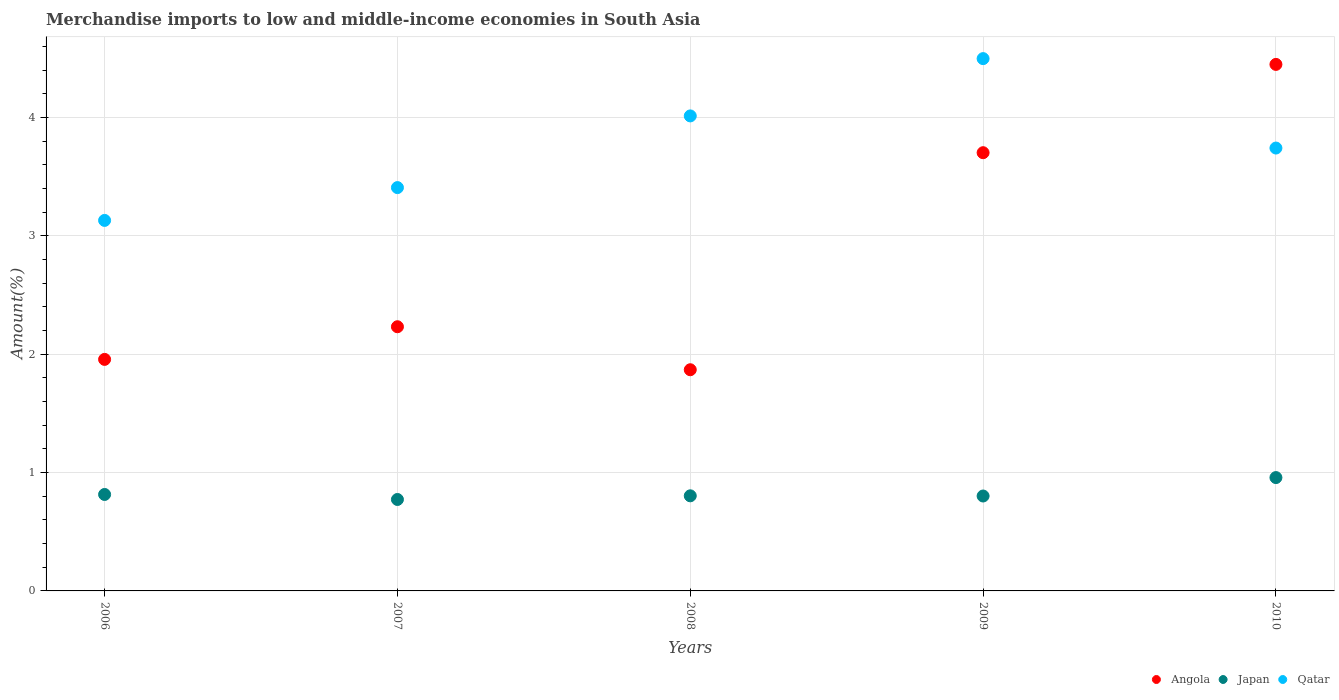Is the number of dotlines equal to the number of legend labels?
Provide a succinct answer. Yes. What is the percentage of amount earned from merchandise imports in Qatar in 2006?
Offer a very short reply. 3.13. Across all years, what is the maximum percentage of amount earned from merchandise imports in Angola?
Provide a short and direct response. 4.45. Across all years, what is the minimum percentage of amount earned from merchandise imports in Qatar?
Ensure brevity in your answer.  3.13. In which year was the percentage of amount earned from merchandise imports in Angola maximum?
Your response must be concise. 2010. What is the total percentage of amount earned from merchandise imports in Qatar in the graph?
Give a very brief answer. 18.79. What is the difference between the percentage of amount earned from merchandise imports in Angola in 2006 and that in 2008?
Keep it short and to the point. 0.09. What is the difference between the percentage of amount earned from merchandise imports in Angola in 2009 and the percentage of amount earned from merchandise imports in Qatar in 2007?
Provide a short and direct response. 0.29. What is the average percentage of amount earned from merchandise imports in Qatar per year?
Offer a terse response. 3.76. In the year 2007, what is the difference between the percentage of amount earned from merchandise imports in Angola and percentage of amount earned from merchandise imports in Qatar?
Your response must be concise. -1.18. In how many years, is the percentage of amount earned from merchandise imports in Angola greater than 4.4 %?
Offer a terse response. 1. What is the ratio of the percentage of amount earned from merchandise imports in Qatar in 2007 to that in 2009?
Provide a succinct answer. 0.76. Is the difference between the percentage of amount earned from merchandise imports in Angola in 2006 and 2008 greater than the difference between the percentage of amount earned from merchandise imports in Qatar in 2006 and 2008?
Make the answer very short. Yes. What is the difference between the highest and the second highest percentage of amount earned from merchandise imports in Qatar?
Give a very brief answer. 0.48. What is the difference between the highest and the lowest percentage of amount earned from merchandise imports in Qatar?
Your response must be concise. 1.37. Is the sum of the percentage of amount earned from merchandise imports in Angola in 2007 and 2009 greater than the maximum percentage of amount earned from merchandise imports in Qatar across all years?
Provide a short and direct response. Yes. Is it the case that in every year, the sum of the percentage of amount earned from merchandise imports in Japan and percentage of amount earned from merchandise imports in Qatar  is greater than the percentage of amount earned from merchandise imports in Angola?
Keep it short and to the point. Yes. Is the percentage of amount earned from merchandise imports in Japan strictly greater than the percentage of amount earned from merchandise imports in Qatar over the years?
Your answer should be compact. No. What is the difference between two consecutive major ticks on the Y-axis?
Offer a terse response. 1. Are the values on the major ticks of Y-axis written in scientific E-notation?
Your answer should be very brief. No. Where does the legend appear in the graph?
Give a very brief answer. Bottom right. How many legend labels are there?
Ensure brevity in your answer.  3. What is the title of the graph?
Provide a short and direct response. Merchandise imports to low and middle-income economies in South Asia. What is the label or title of the X-axis?
Provide a succinct answer. Years. What is the label or title of the Y-axis?
Give a very brief answer. Amount(%). What is the Amount(%) of Angola in 2006?
Offer a very short reply. 1.96. What is the Amount(%) of Japan in 2006?
Your response must be concise. 0.82. What is the Amount(%) in Qatar in 2006?
Keep it short and to the point. 3.13. What is the Amount(%) in Angola in 2007?
Provide a succinct answer. 2.23. What is the Amount(%) of Japan in 2007?
Your response must be concise. 0.77. What is the Amount(%) of Qatar in 2007?
Make the answer very short. 3.41. What is the Amount(%) of Angola in 2008?
Offer a terse response. 1.87. What is the Amount(%) of Japan in 2008?
Your answer should be very brief. 0.8. What is the Amount(%) of Qatar in 2008?
Offer a terse response. 4.01. What is the Amount(%) in Angola in 2009?
Provide a succinct answer. 3.7. What is the Amount(%) of Japan in 2009?
Ensure brevity in your answer.  0.8. What is the Amount(%) of Qatar in 2009?
Ensure brevity in your answer.  4.5. What is the Amount(%) of Angola in 2010?
Make the answer very short. 4.45. What is the Amount(%) of Japan in 2010?
Provide a succinct answer. 0.96. What is the Amount(%) of Qatar in 2010?
Provide a succinct answer. 3.74. Across all years, what is the maximum Amount(%) of Angola?
Your response must be concise. 4.45. Across all years, what is the maximum Amount(%) in Japan?
Keep it short and to the point. 0.96. Across all years, what is the maximum Amount(%) of Qatar?
Your answer should be very brief. 4.5. Across all years, what is the minimum Amount(%) in Angola?
Provide a short and direct response. 1.87. Across all years, what is the minimum Amount(%) of Japan?
Keep it short and to the point. 0.77. Across all years, what is the minimum Amount(%) in Qatar?
Offer a very short reply. 3.13. What is the total Amount(%) in Angola in the graph?
Keep it short and to the point. 14.21. What is the total Amount(%) of Japan in the graph?
Your answer should be compact. 4.15. What is the total Amount(%) in Qatar in the graph?
Provide a short and direct response. 18.79. What is the difference between the Amount(%) in Angola in 2006 and that in 2007?
Your response must be concise. -0.28. What is the difference between the Amount(%) in Japan in 2006 and that in 2007?
Keep it short and to the point. 0.04. What is the difference between the Amount(%) in Qatar in 2006 and that in 2007?
Give a very brief answer. -0.28. What is the difference between the Amount(%) in Angola in 2006 and that in 2008?
Provide a succinct answer. 0.09. What is the difference between the Amount(%) in Japan in 2006 and that in 2008?
Offer a very short reply. 0.01. What is the difference between the Amount(%) in Qatar in 2006 and that in 2008?
Your answer should be compact. -0.88. What is the difference between the Amount(%) of Angola in 2006 and that in 2009?
Your response must be concise. -1.75. What is the difference between the Amount(%) in Japan in 2006 and that in 2009?
Offer a very short reply. 0.01. What is the difference between the Amount(%) in Qatar in 2006 and that in 2009?
Offer a very short reply. -1.37. What is the difference between the Amount(%) in Angola in 2006 and that in 2010?
Your response must be concise. -2.49. What is the difference between the Amount(%) in Japan in 2006 and that in 2010?
Make the answer very short. -0.14. What is the difference between the Amount(%) in Qatar in 2006 and that in 2010?
Your answer should be very brief. -0.61. What is the difference between the Amount(%) of Angola in 2007 and that in 2008?
Give a very brief answer. 0.36. What is the difference between the Amount(%) in Japan in 2007 and that in 2008?
Keep it short and to the point. -0.03. What is the difference between the Amount(%) in Qatar in 2007 and that in 2008?
Provide a short and direct response. -0.61. What is the difference between the Amount(%) in Angola in 2007 and that in 2009?
Your answer should be very brief. -1.47. What is the difference between the Amount(%) of Japan in 2007 and that in 2009?
Your response must be concise. -0.03. What is the difference between the Amount(%) in Qatar in 2007 and that in 2009?
Keep it short and to the point. -1.09. What is the difference between the Amount(%) of Angola in 2007 and that in 2010?
Give a very brief answer. -2.22. What is the difference between the Amount(%) in Japan in 2007 and that in 2010?
Offer a terse response. -0.19. What is the difference between the Amount(%) of Qatar in 2007 and that in 2010?
Provide a short and direct response. -0.33. What is the difference between the Amount(%) of Angola in 2008 and that in 2009?
Offer a very short reply. -1.83. What is the difference between the Amount(%) in Japan in 2008 and that in 2009?
Your response must be concise. 0. What is the difference between the Amount(%) of Qatar in 2008 and that in 2009?
Give a very brief answer. -0.48. What is the difference between the Amount(%) in Angola in 2008 and that in 2010?
Offer a terse response. -2.58. What is the difference between the Amount(%) in Japan in 2008 and that in 2010?
Make the answer very short. -0.15. What is the difference between the Amount(%) in Qatar in 2008 and that in 2010?
Give a very brief answer. 0.27. What is the difference between the Amount(%) in Angola in 2009 and that in 2010?
Provide a short and direct response. -0.75. What is the difference between the Amount(%) in Japan in 2009 and that in 2010?
Make the answer very short. -0.16. What is the difference between the Amount(%) of Qatar in 2009 and that in 2010?
Provide a short and direct response. 0.76. What is the difference between the Amount(%) of Angola in 2006 and the Amount(%) of Japan in 2007?
Provide a short and direct response. 1.18. What is the difference between the Amount(%) in Angola in 2006 and the Amount(%) in Qatar in 2007?
Provide a succinct answer. -1.45. What is the difference between the Amount(%) in Japan in 2006 and the Amount(%) in Qatar in 2007?
Your answer should be compact. -2.59. What is the difference between the Amount(%) in Angola in 2006 and the Amount(%) in Japan in 2008?
Offer a terse response. 1.15. What is the difference between the Amount(%) in Angola in 2006 and the Amount(%) in Qatar in 2008?
Give a very brief answer. -2.06. What is the difference between the Amount(%) in Japan in 2006 and the Amount(%) in Qatar in 2008?
Make the answer very short. -3.2. What is the difference between the Amount(%) in Angola in 2006 and the Amount(%) in Japan in 2009?
Your response must be concise. 1.15. What is the difference between the Amount(%) of Angola in 2006 and the Amount(%) of Qatar in 2009?
Offer a very short reply. -2.54. What is the difference between the Amount(%) of Japan in 2006 and the Amount(%) of Qatar in 2009?
Ensure brevity in your answer.  -3.68. What is the difference between the Amount(%) in Angola in 2006 and the Amount(%) in Qatar in 2010?
Your answer should be very brief. -1.79. What is the difference between the Amount(%) of Japan in 2006 and the Amount(%) of Qatar in 2010?
Make the answer very short. -2.93. What is the difference between the Amount(%) in Angola in 2007 and the Amount(%) in Japan in 2008?
Offer a terse response. 1.43. What is the difference between the Amount(%) in Angola in 2007 and the Amount(%) in Qatar in 2008?
Offer a terse response. -1.78. What is the difference between the Amount(%) of Japan in 2007 and the Amount(%) of Qatar in 2008?
Your response must be concise. -3.24. What is the difference between the Amount(%) in Angola in 2007 and the Amount(%) in Japan in 2009?
Ensure brevity in your answer.  1.43. What is the difference between the Amount(%) in Angola in 2007 and the Amount(%) in Qatar in 2009?
Your answer should be very brief. -2.27. What is the difference between the Amount(%) in Japan in 2007 and the Amount(%) in Qatar in 2009?
Make the answer very short. -3.73. What is the difference between the Amount(%) of Angola in 2007 and the Amount(%) of Japan in 2010?
Make the answer very short. 1.27. What is the difference between the Amount(%) in Angola in 2007 and the Amount(%) in Qatar in 2010?
Make the answer very short. -1.51. What is the difference between the Amount(%) in Japan in 2007 and the Amount(%) in Qatar in 2010?
Provide a short and direct response. -2.97. What is the difference between the Amount(%) in Angola in 2008 and the Amount(%) in Japan in 2009?
Make the answer very short. 1.07. What is the difference between the Amount(%) in Angola in 2008 and the Amount(%) in Qatar in 2009?
Offer a terse response. -2.63. What is the difference between the Amount(%) in Japan in 2008 and the Amount(%) in Qatar in 2009?
Your response must be concise. -3.69. What is the difference between the Amount(%) in Angola in 2008 and the Amount(%) in Japan in 2010?
Offer a terse response. 0.91. What is the difference between the Amount(%) in Angola in 2008 and the Amount(%) in Qatar in 2010?
Give a very brief answer. -1.87. What is the difference between the Amount(%) in Japan in 2008 and the Amount(%) in Qatar in 2010?
Your answer should be compact. -2.94. What is the difference between the Amount(%) in Angola in 2009 and the Amount(%) in Japan in 2010?
Keep it short and to the point. 2.75. What is the difference between the Amount(%) in Angola in 2009 and the Amount(%) in Qatar in 2010?
Provide a short and direct response. -0.04. What is the difference between the Amount(%) of Japan in 2009 and the Amount(%) of Qatar in 2010?
Offer a terse response. -2.94. What is the average Amount(%) in Angola per year?
Give a very brief answer. 2.84. What is the average Amount(%) of Japan per year?
Your response must be concise. 0.83. What is the average Amount(%) of Qatar per year?
Provide a succinct answer. 3.76. In the year 2006, what is the difference between the Amount(%) in Angola and Amount(%) in Japan?
Make the answer very short. 1.14. In the year 2006, what is the difference between the Amount(%) in Angola and Amount(%) in Qatar?
Offer a terse response. -1.17. In the year 2006, what is the difference between the Amount(%) of Japan and Amount(%) of Qatar?
Keep it short and to the point. -2.32. In the year 2007, what is the difference between the Amount(%) of Angola and Amount(%) of Japan?
Your answer should be very brief. 1.46. In the year 2007, what is the difference between the Amount(%) of Angola and Amount(%) of Qatar?
Ensure brevity in your answer.  -1.18. In the year 2007, what is the difference between the Amount(%) in Japan and Amount(%) in Qatar?
Ensure brevity in your answer.  -2.64. In the year 2008, what is the difference between the Amount(%) of Angola and Amount(%) of Japan?
Provide a succinct answer. 1.07. In the year 2008, what is the difference between the Amount(%) in Angola and Amount(%) in Qatar?
Offer a terse response. -2.14. In the year 2008, what is the difference between the Amount(%) in Japan and Amount(%) in Qatar?
Make the answer very short. -3.21. In the year 2009, what is the difference between the Amount(%) of Angola and Amount(%) of Japan?
Your answer should be very brief. 2.9. In the year 2009, what is the difference between the Amount(%) in Angola and Amount(%) in Qatar?
Ensure brevity in your answer.  -0.8. In the year 2009, what is the difference between the Amount(%) in Japan and Amount(%) in Qatar?
Your response must be concise. -3.7. In the year 2010, what is the difference between the Amount(%) of Angola and Amount(%) of Japan?
Your response must be concise. 3.49. In the year 2010, what is the difference between the Amount(%) of Angola and Amount(%) of Qatar?
Your answer should be very brief. 0.71. In the year 2010, what is the difference between the Amount(%) in Japan and Amount(%) in Qatar?
Give a very brief answer. -2.78. What is the ratio of the Amount(%) of Angola in 2006 to that in 2007?
Make the answer very short. 0.88. What is the ratio of the Amount(%) in Japan in 2006 to that in 2007?
Your answer should be compact. 1.05. What is the ratio of the Amount(%) of Qatar in 2006 to that in 2007?
Your answer should be compact. 0.92. What is the ratio of the Amount(%) of Angola in 2006 to that in 2008?
Offer a terse response. 1.05. What is the ratio of the Amount(%) in Japan in 2006 to that in 2008?
Your response must be concise. 1.01. What is the ratio of the Amount(%) of Qatar in 2006 to that in 2008?
Offer a terse response. 0.78. What is the ratio of the Amount(%) of Angola in 2006 to that in 2009?
Give a very brief answer. 0.53. What is the ratio of the Amount(%) of Japan in 2006 to that in 2009?
Provide a succinct answer. 1.02. What is the ratio of the Amount(%) in Qatar in 2006 to that in 2009?
Your answer should be very brief. 0.7. What is the ratio of the Amount(%) of Angola in 2006 to that in 2010?
Keep it short and to the point. 0.44. What is the ratio of the Amount(%) in Japan in 2006 to that in 2010?
Give a very brief answer. 0.85. What is the ratio of the Amount(%) in Qatar in 2006 to that in 2010?
Your answer should be compact. 0.84. What is the ratio of the Amount(%) of Angola in 2007 to that in 2008?
Keep it short and to the point. 1.19. What is the ratio of the Amount(%) in Japan in 2007 to that in 2008?
Make the answer very short. 0.96. What is the ratio of the Amount(%) of Qatar in 2007 to that in 2008?
Offer a very short reply. 0.85. What is the ratio of the Amount(%) in Angola in 2007 to that in 2009?
Provide a short and direct response. 0.6. What is the ratio of the Amount(%) in Japan in 2007 to that in 2009?
Offer a very short reply. 0.96. What is the ratio of the Amount(%) in Qatar in 2007 to that in 2009?
Give a very brief answer. 0.76. What is the ratio of the Amount(%) in Angola in 2007 to that in 2010?
Provide a short and direct response. 0.5. What is the ratio of the Amount(%) in Japan in 2007 to that in 2010?
Your response must be concise. 0.81. What is the ratio of the Amount(%) in Qatar in 2007 to that in 2010?
Your response must be concise. 0.91. What is the ratio of the Amount(%) of Angola in 2008 to that in 2009?
Provide a succinct answer. 0.5. What is the ratio of the Amount(%) in Qatar in 2008 to that in 2009?
Your answer should be very brief. 0.89. What is the ratio of the Amount(%) in Angola in 2008 to that in 2010?
Offer a very short reply. 0.42. What is the ratio of the Amount(%) in Japan in 2008 to that in 2010?
Make the answer very short. 0.84. What is the ratio of the Amount(%) of Qatar in 2008 to that in 2010?
Offer a terse response. 1.07. What is the ratio of the Amount(%) of Angola in 2009 to that in 2010?
Your response must be concise. 0.83. What is the ratio of the Amount(%) of Japan in 2009 to that in 2010?
Your answer should be very brief. 0.84. What is the ratio of the Amount(%) in Qatar in 2009 to that in 2010?
Provide a succinct answer. 1.2. What is the difference between the highest and the second highest Amount(%) of Angola?
Ensure brevity in your answer.  0.75. What is the difference between the highest and the second highest Amount(%) of Japan?
Provide a succinct answer. 0.14. What is the difference between the highest and the second highest Amount(%) of Qatar?
Provide a short and direct response. 0.48. What is the difference between the highest and the lowest Amount(%) in Angola?
Offer a very short reply. 2.58. What is the difference between the highest and the lowest Amount(%) of Japan?
Offer a very short reply. 0.19. What is the difference between the highest and the lowest Amount(%) in Qatar?
Keep it short and to the point. 1.37. 